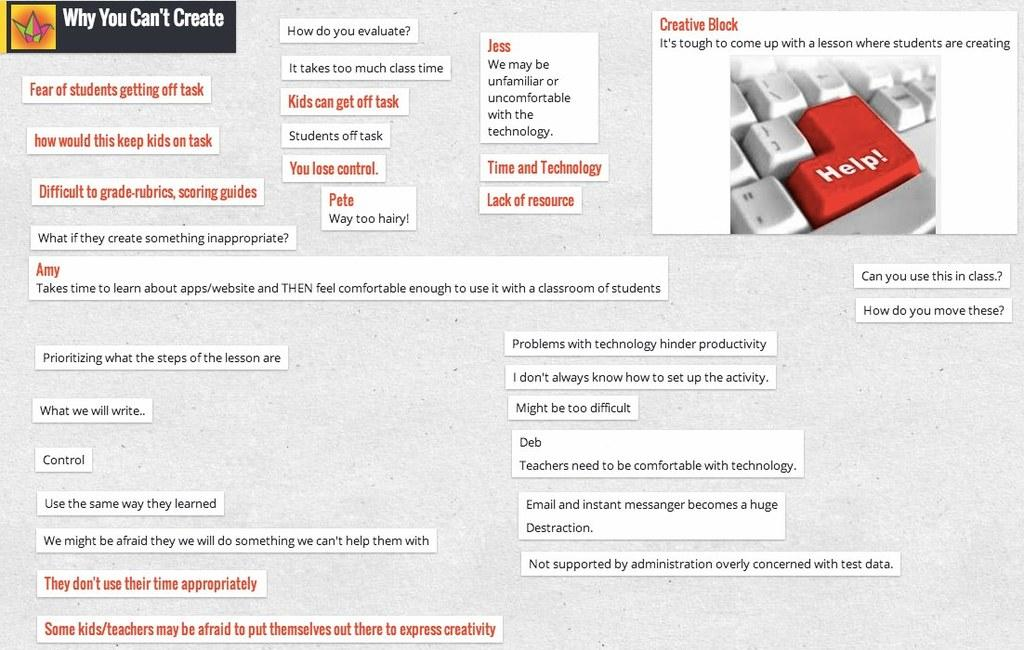<image>
Render a clear and concise summary of the photo. a poster for "Why you create" with a red key reading Help 